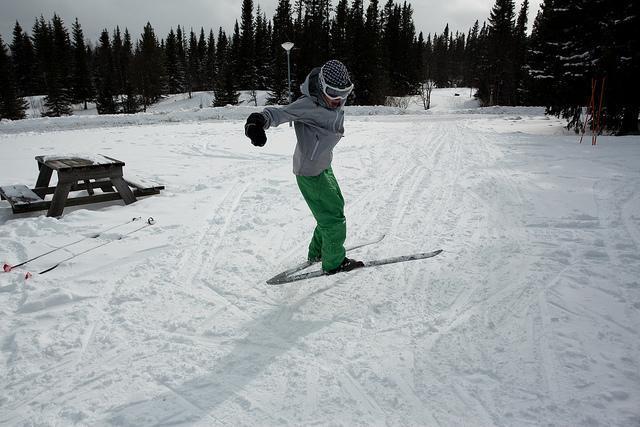How many benches can be seen?
Give a very brief answer. 1. 